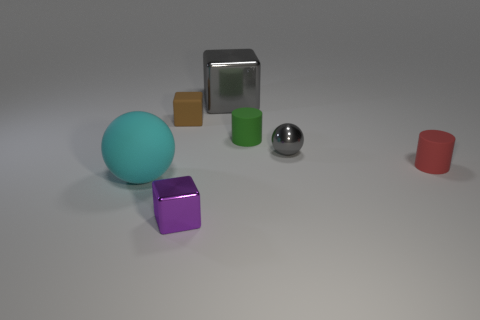Does the red object have the same material as the small purple thing?
Your answer should be very brief. No. What number of matte things are both to the right of the small purple metallic block and behind the small gray metallic thing?
Your answer should be very brief. 1. What number of other objects are the same color as the large cube?
Keep it short and to the point. 1. How many gray objects are shiny spheres or tiny matte cylinders?
Ensure brevity in your answer.  1. The red rubber thing has what size?
Provide a succinct answer. Small. How many metallic things are big things or balls?
Provide a short and direct response. 2. Are there fewer gray spheres than green matte spheres?
Ensure brevity in your answer.  No. What number of other things are the same material as the red cylinder?
Your response must be concise. 3. There is a gray metal object that is the same shape as the tiny purple thing; what size is it?
Your answer should be compact. Large. Do the big thing that is in front of the gray metallic sphere and the green thing in front of the tiny matte cube have the same material?
Provide a succinct answer. Yes. 